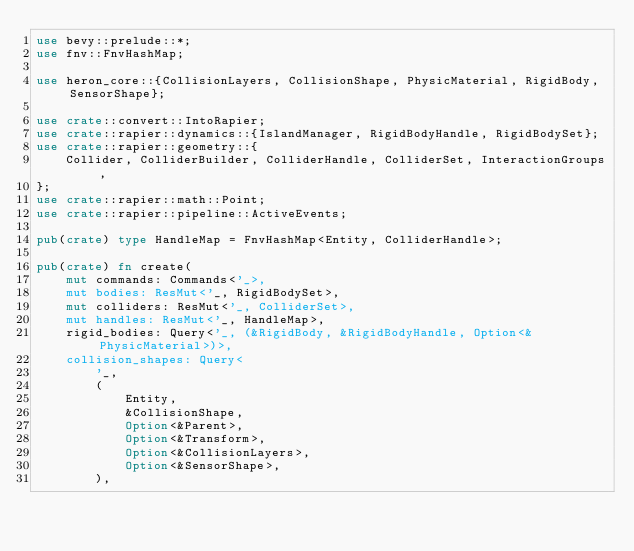Convert code to text. <code><loc_0><loc_0><loc_500><loc_500><_Rust_>use bevy::prelude::*;
use fnv::FnvHashMap;

use heron_core::{CollisionLayers, CollisionShape, PhysicMaterial, RigidBody, SensorShape};

use crate::convert::IntoRapier;
use crate::rapier::dynamics::{IslandManager, RigidBodyHandle, RigidBodySet};
use crate::rapier::geometry::{
    Collider, ColliderBuilder, ColliderHandle, ColliderSet, InteractionGroups,
};
use crate::rapier::math::Point;
use crate::rapier::pipeline::ActiveEvents;

pub(crate) type HandleMap = FnvHashMap<Entity, ColliderHandle>;

pub(crate) fn create(
    mut commands: Commands<'_>,
    mut bodies: ResMut<'_, RigidBodySet>,
    mut colliders: ResMut<'_, ColliderSet>,
    mut handles: ResMut<'_, HandleMap>,
    rigid_bodies: Query<'_, (&RigidBody, &RigidBodyHandle, Option<&PhysicMaterial>)>,
    collision_shapes: Query<
        '_,
        (
            Entity,
            &CollisionShape,
            Option<&Parent>,
            Option<&Transform>,
            Option<&CollisionLayers>,
            Option<&SensorShape>,
        ),</code> 